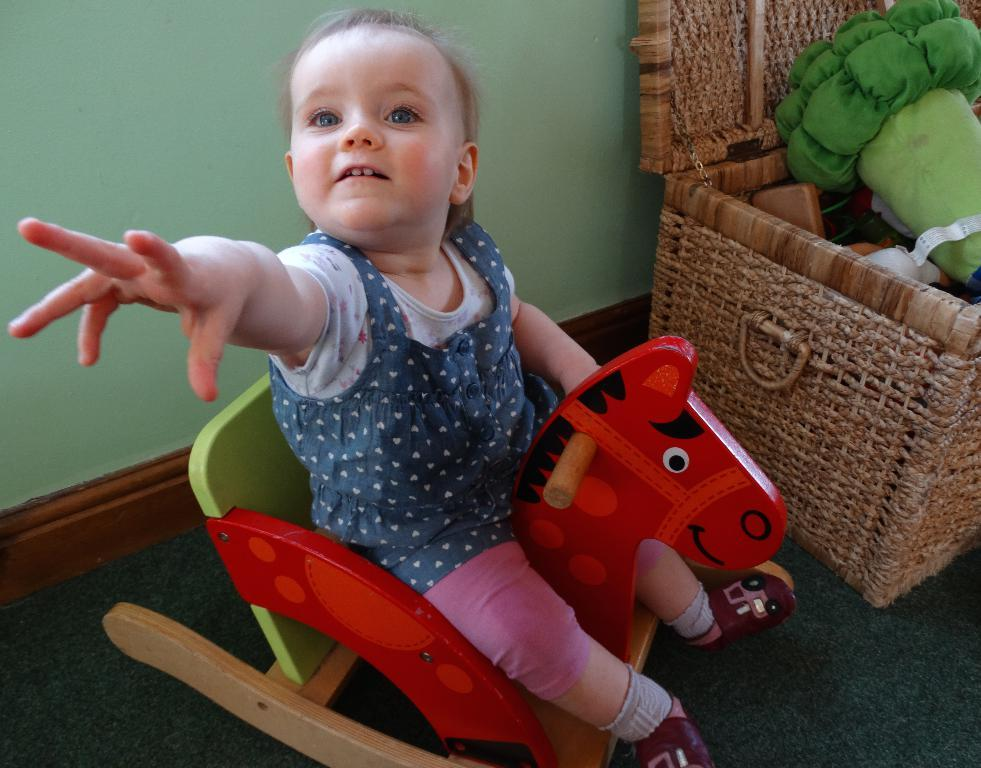What is the main subject of the image? There is a kid sitting in a chair in the center of the image. What can be seen on the right side of the image? There is a basket on the right side of the image. What is inside the basket? The basket contains toys. What color is the wall behind the kid? The wall behind the kid is painted green. What type of trade is happening in the image? There is no trade happening in the image; it features a kid sitting in a chair with a basket of toys nearby. What does the image smell like? The image does not have a smell; it is a visual representation. 